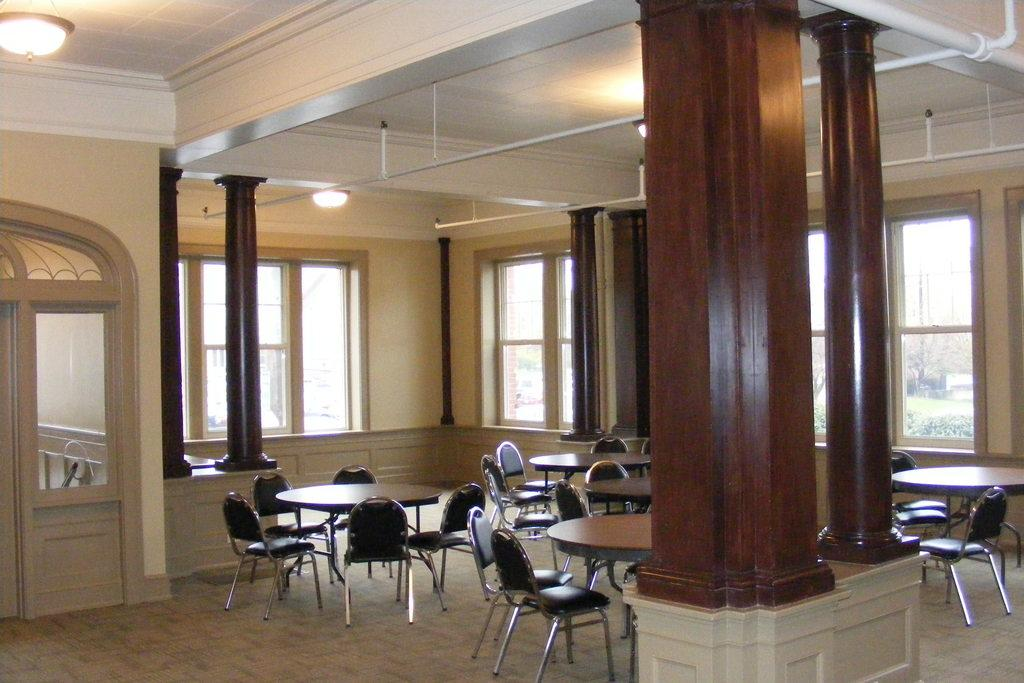What type of setting is depicted in the image? The image shows an inside view of a house. What architectural features can be seen in the house? There are windows, pillars, and a door visible in the house. What furniture items are present in the house? There are stands, chairs, and tables in the house. What is used for illumination in the house? There are lights in the house. Can you see any fish swimming in the house in the image? There are no fish visible in the image; it shows an inside view of a house with various architectural and furniture elements. What type of line is used to connect the pillars in the house? There is no line connecting the pillars in the house; the pillars are separate architectural elements. 